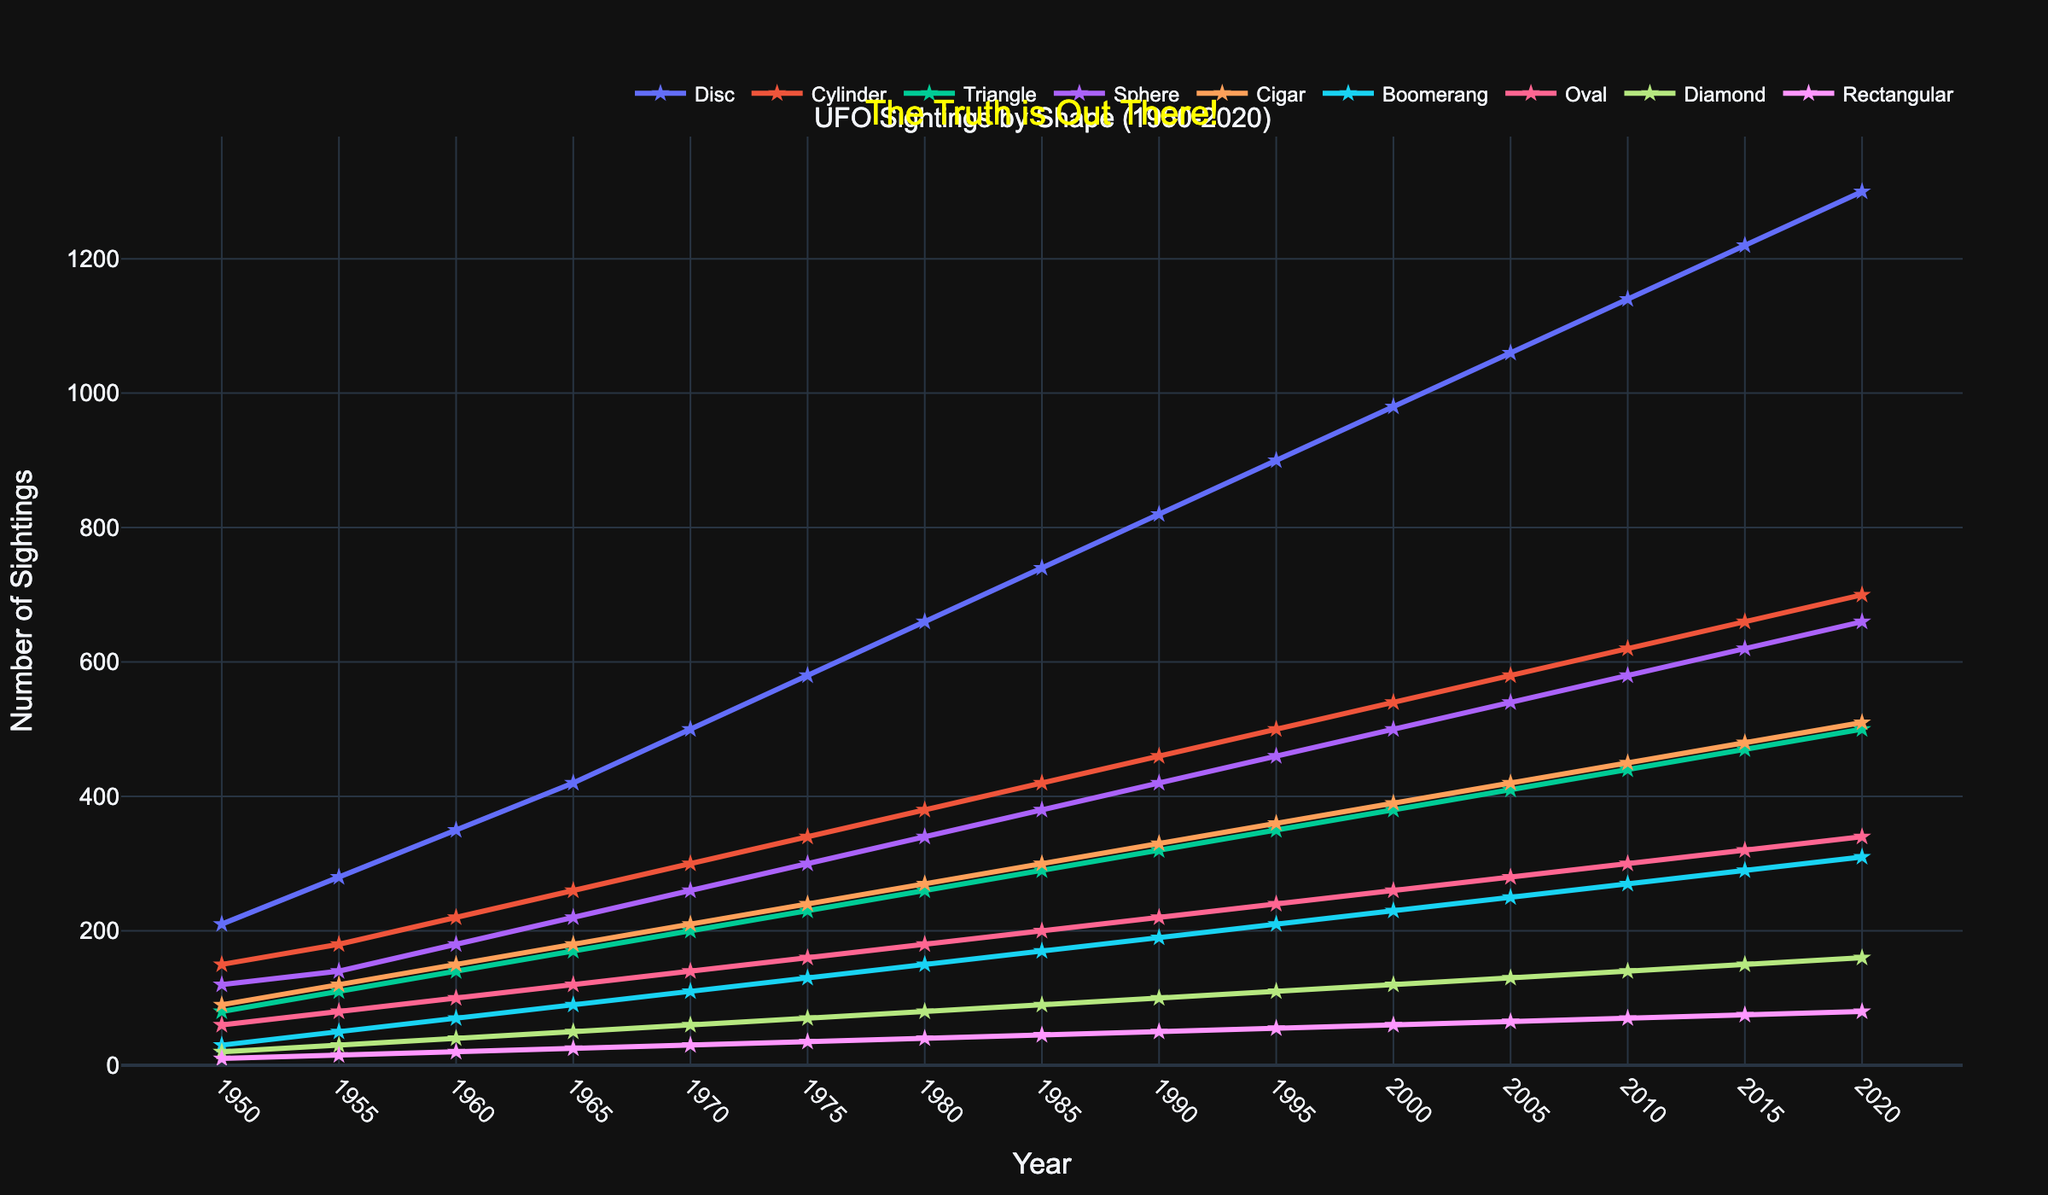What is the general trend of UFO sightings for Disc-shaped objects from 1950 to 2020? To determine the trend, observe the line representing Disc-shaped sightings from left (1950) to right (2020). The line consistently rises, indicating an increasing number of Disc-shaped sightings over time.
Answer: Increasing Compare the number of Triangle-shaped UFO sightings in 1960 and 2020. In 1960, the data for Triangle-shaped sightings is 140. In 2020, it is 500. Clearly, 500 (2020) is much greater than 140 (1960).
Answer: 2020 is greater Which year had the highest number of overall UFO sightings across all shapes? To find the year with the highest total sightings, sum the values for each year and compare. For 2020, the total sightings (Disc + Cylinder + Triangle + Sphere + Cigar + Boomerang + Oval + Diamond + Rectangular) is 1300 + 700 + 500 + 660 + 510 + 310 + 340 + 160 + 80 = 4560, which is the highest compared to other years.
Answer: 2020 What is the ratio of spherical UFO sightings to cigar-shaped sightings in the year 1985? In 1985, spherical sightings are 380, and cigar-shaped sightings are 300. The ratio is calculated as 380 / 300 = 1.267.
Answer: 1.267 Which shape has the steadiest increase in sightings from 1950 to 2020? By comparing the slope and steadiness of each line, Disc-shaped UFOs show the most consistent increase without major fluctuations.
Answer: Disc Between 1970 and 1990, which shape had the smallest increase in sightings? From the data, subtract the 1970 values from the 1990 values for each shape and identify the smallest difference. The smallest increase is for Diamond-shaped sightings, with an increase of 100 - 60 = 40.
Answer: Diamond By how much did the number of Boomerang-shaped UFO sightings increase from 1950 to 2020? Boomerang sightings in 1950 were 30, and in 2020 they were 310. The increase is 310 - 30 = 280.
Answer: 280 What can you say about the change in the number of Oval-shaped sightings from 2000 to 2015? Oval sightings in 2000 were 260, and in 2015 they were 320. The change (increase) is 320 - 260 = 60.
Answer: Increased by 60 